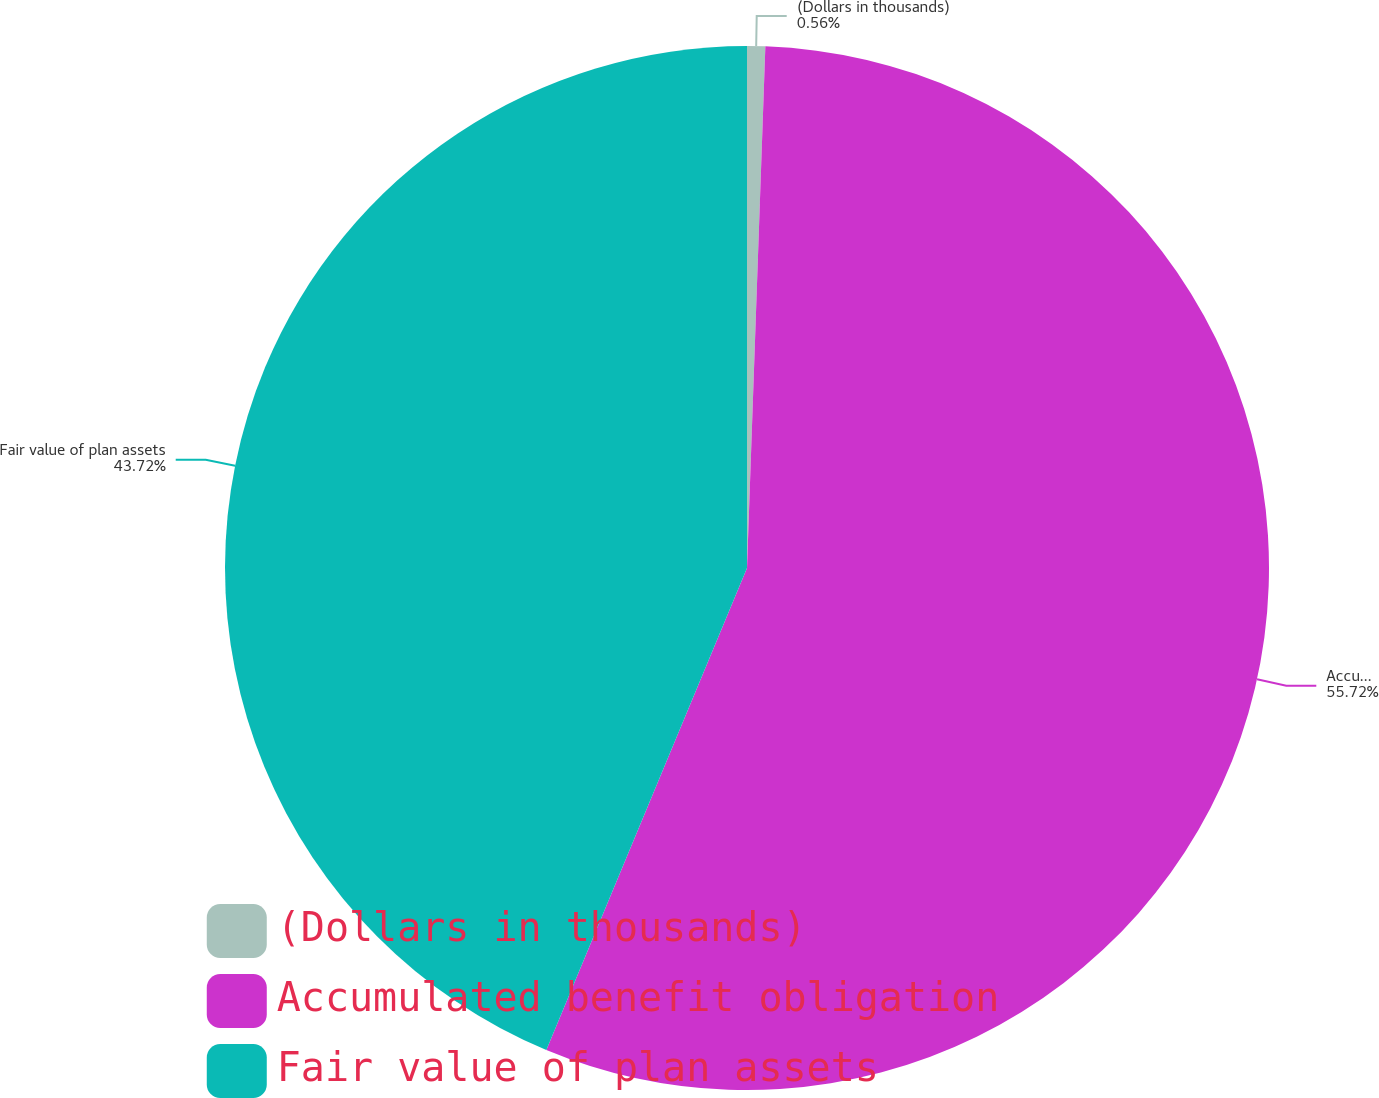<chart> <loc_0><loc_0><loc_500><loc_500><pie_chart><fcel>(Dollars in thousands)<fcel>Accumulated benefit obligation<fcel>Fair value of plan assets<nl><fcel>0.56%<fcel>55.72%<fcel>43.72%<nl></chart> 